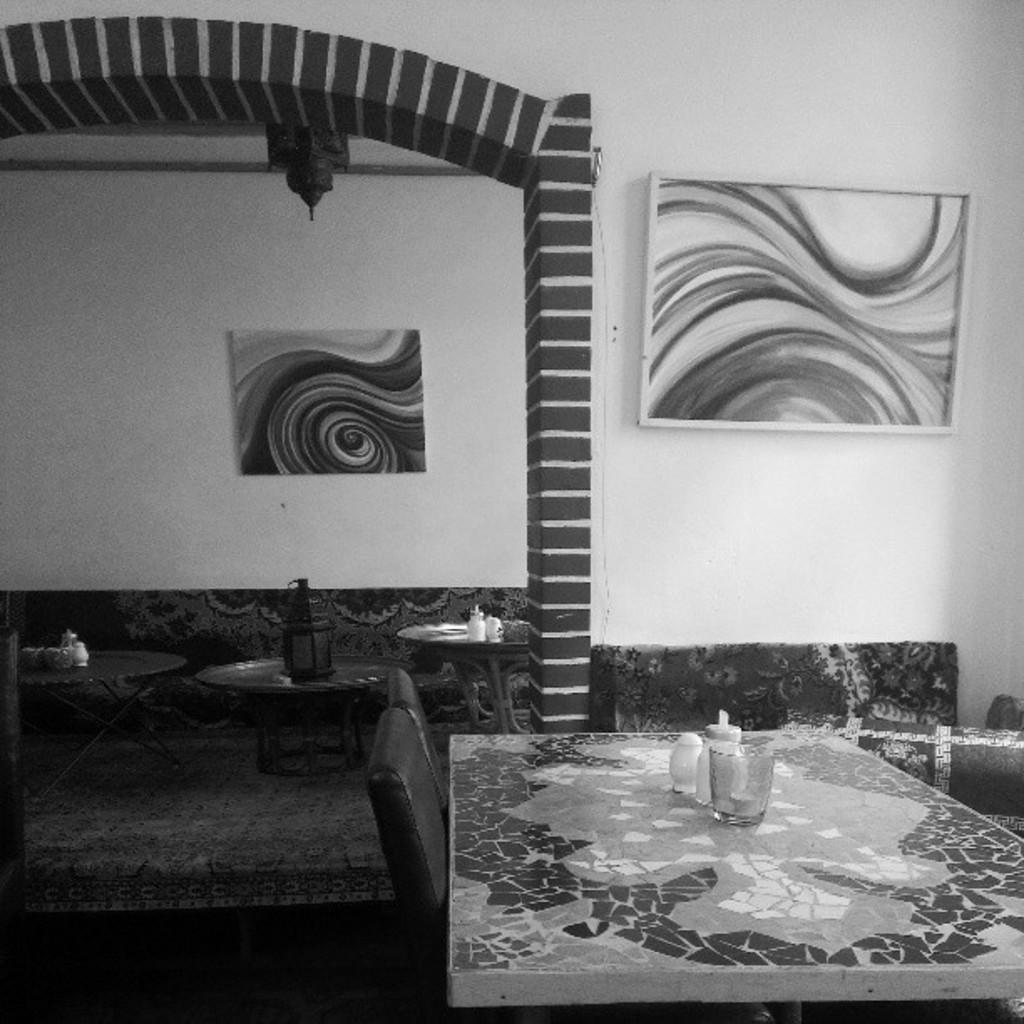What is the main structure in the image? There is a frame in the image. What type of background can be seen in the image? There is a wall in the image. What type of furniture is present in the image? There are chairs and a table in the image. What is on the table? There is a glass on the table, and there are other objects on the table as well. What is the floor like in the image? The image shows a floor. How many mice are attempting to use the wrench on the table in the image? There are no mice or wrenches present in the image. 